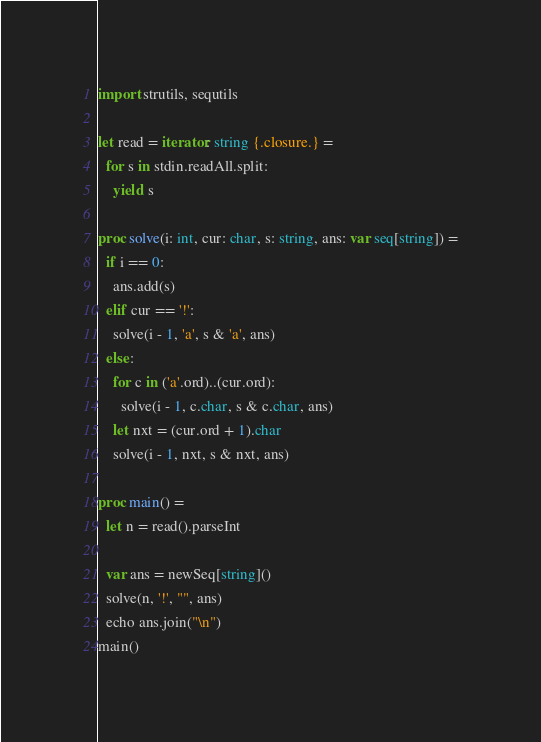Convert code to text. <code><loc_0><loc_0><loc_500><loc_500><_Nim_>import strutils, sequtils

let read = iterator: string {.closure.} =
  for s in stdin.readAll.split:
    yield s

proc solve(i: int, cur: char, s: string, ans: var seq[string]) =
  if i == 0:
    ans.add(s)
  elif cur == '!':
    solve(i - 1, 'a', s & 'a', ans)
  else:
    for c in ('a'.ord)..(cur.ord):
      solve(i - 1, c.char, s & c.char, ans)
    let nxt = (cur.ord + 1).char
    solve(i - 1, nxt, s & nxt, ans)

proc main() =
  let n = read().parseInt

  var ans = newSeq[string]()
  solve(n, '!', "", ans)
  echo ans.join("\n")
main()
</code> 